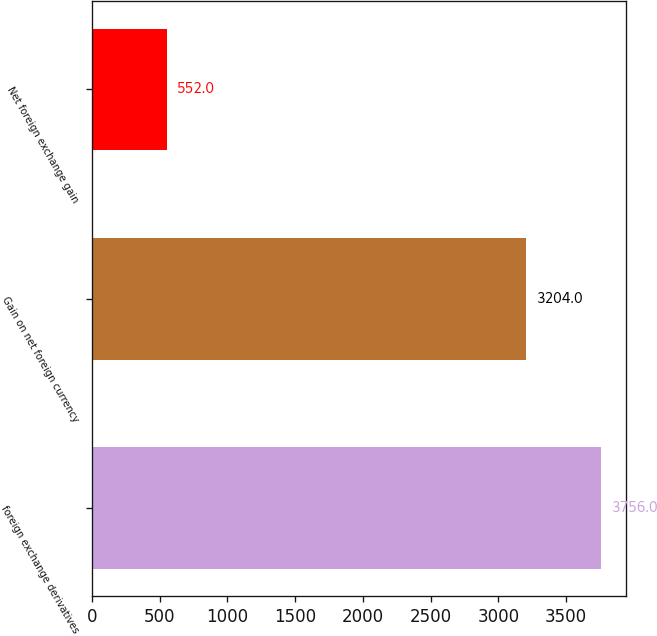Convert chart to OTSL. <chart><loc_0><loc_0><loc_500><loc_500><bar_chart><fcel>foreign exchange derivatives<fcel>Gain on net foreign currency<fcel>Net foreign exchange gain<nl><fcel>3756<fcel>3204<fcel>552<nl></chart> 